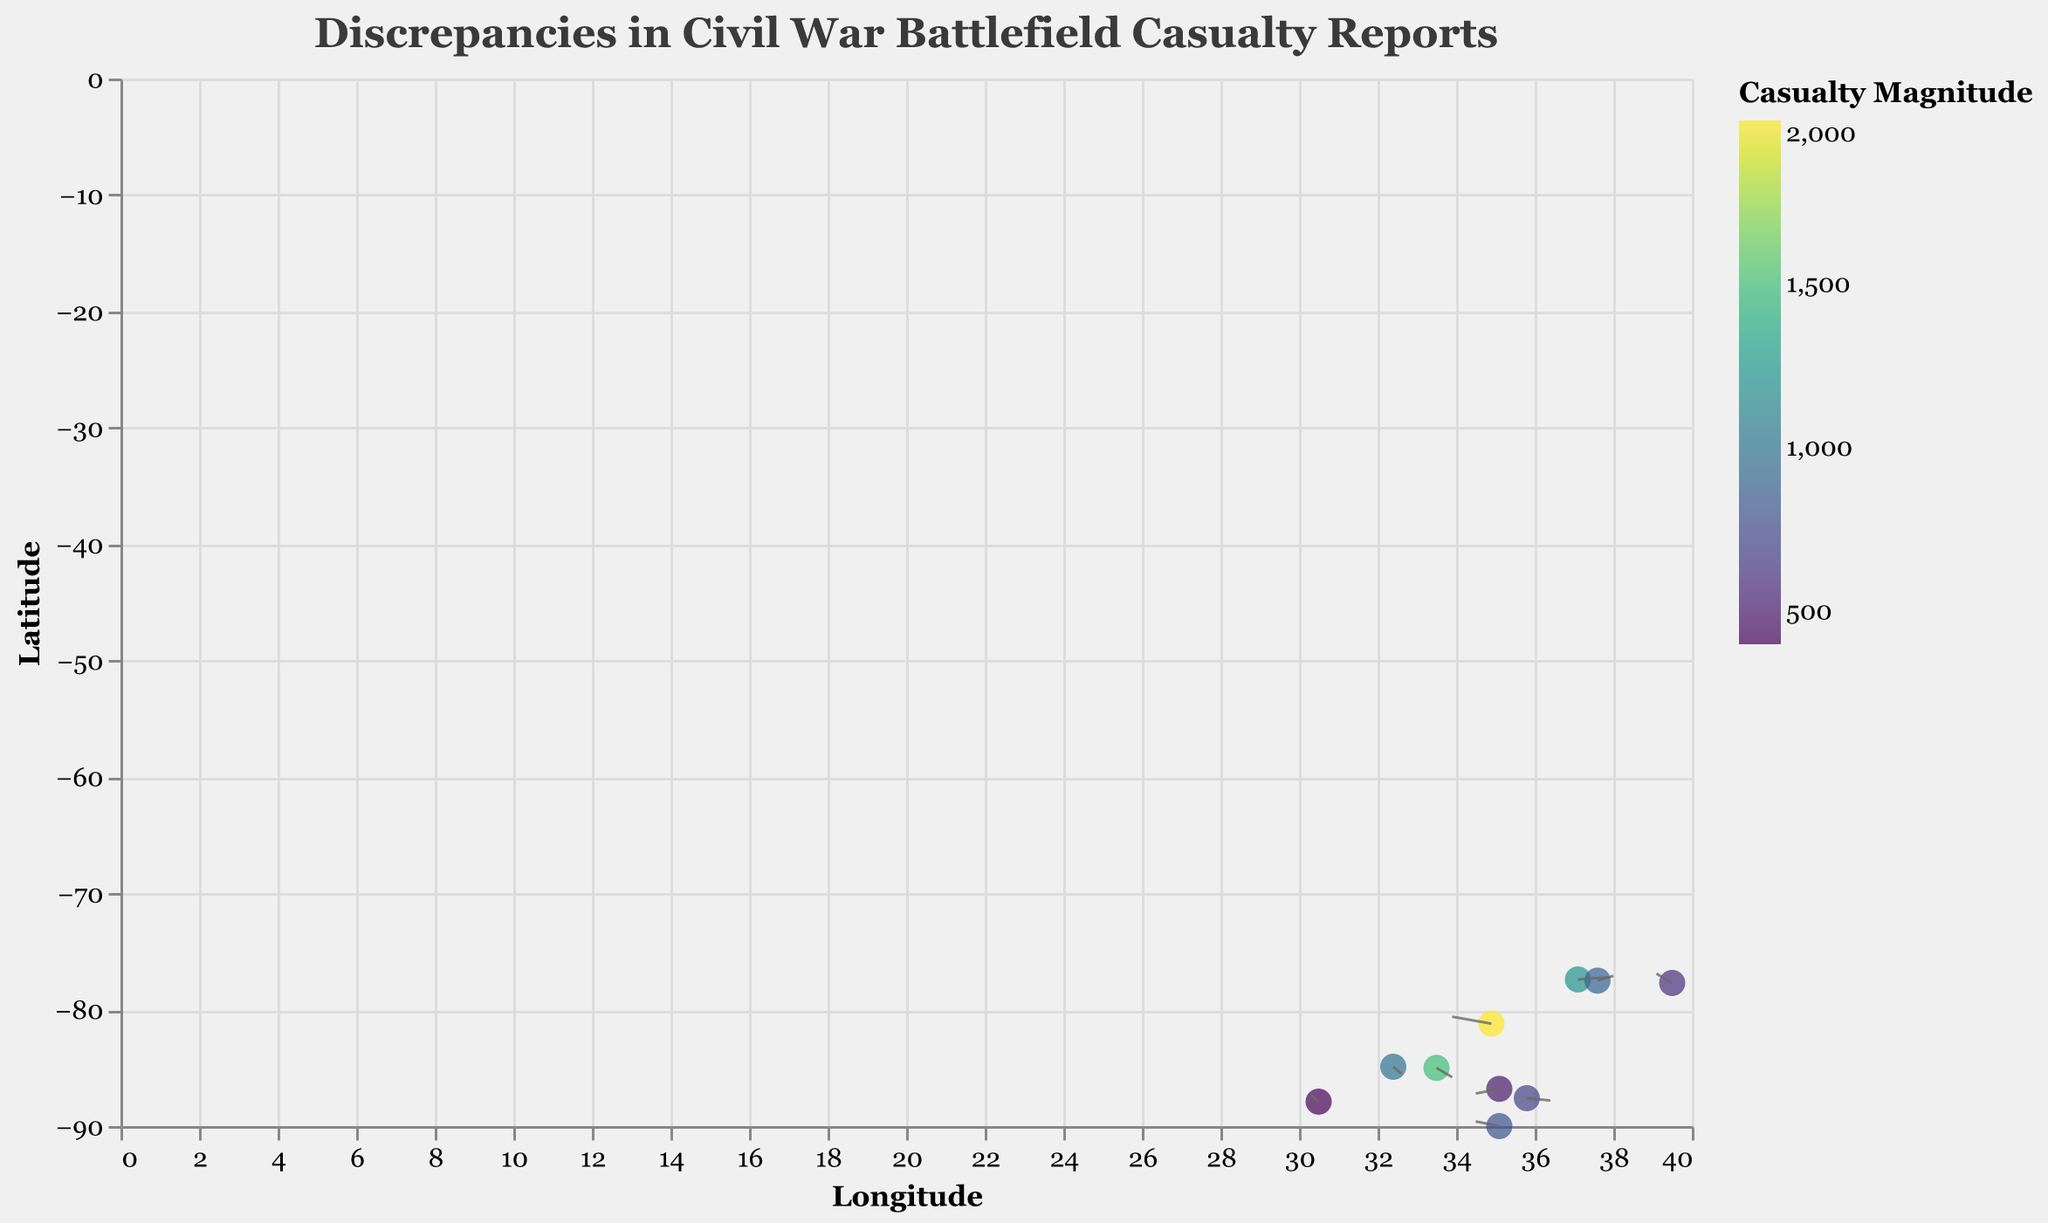What is the title of the figure? The title is often located at the top of a figure and provides a summary of what the figure is depicting. By observing the top of the figure, you can see that it reads "Discrepancies in Civil War Battlefield Casualty Reports".
Answer: Discrepancies in Civil War Battlefield Casualty Reports How many data points are represented in the chart? Count the number of distinct points or markers on the figure. There are 10 distinct battles indicated by points in the chart.
Answer: 10 Which battle has the highest casualty magnitude represented in the chart? Look for the data point with the largest marker size or color intensity, as this indicates a higher casualty magnitude. The point representing Gettysburg has the highest magnitude at 2000.
Answer: Gettysburg What are the coordinates (Longitude, Latitude) for the battle of Franklin? Identify the point labeled as "Franklin" and note its coordinates. The coordinates for Franklin are approximately (35.8, -87.6).
Answer: (35.8, -87.6) For which battle is the discrepancy vector pointing in the negative direction along both axes? Examine the direction of the arrows (vectors) from each point. The vector for Stones River points negatively along both the x-axis and y-axis.
Answer: Stones River What is the average casualty magnitude of the battles represented in this plot? Sum all the casualty magnitudes and divide by the number of data points. Sum = 2000 + 1500 + 1200 + 800 + 1000 + 600 + 700 + 400 + 900 + 500 = 9600. The average is 9600 / 10 = 960.
Answer: 960 Which battle shows a discrepancy vector with the largest horizontal component? Look for the vector with the largest absolute value in the x-direction (u component). The battle of Gettysburg has a horizontal component of -0.5.
Answer: Gettysburg Between the battles of Shiloh and Antietam, which battle's vector points more vertically? Compare the vertical (v) components of the vectors for Shiloh and Antietam. Shiloh has a v component of 0.2, and Antietam has a v component of 0.4. Antietam's vector points more vertically.
Answer: Antietam Which location (coordinates) shows a vector indicating the smallest discrepancy? Look for the smallest magnitude vector. This can be deduced by observing the shortest arrow. Mobile Bay has the smallest magnitude at 400.
Answer: Mobile Bay For the battle of Cold Harbor, in which direction does the discrepancy vector point? Observe the direction of the arrow from the data point for Cold Harbor. The vector for Cold Harbor points in the positive direction for both axes (u: 0.2, v: 0.2).
Answer: Positive x and y direction 